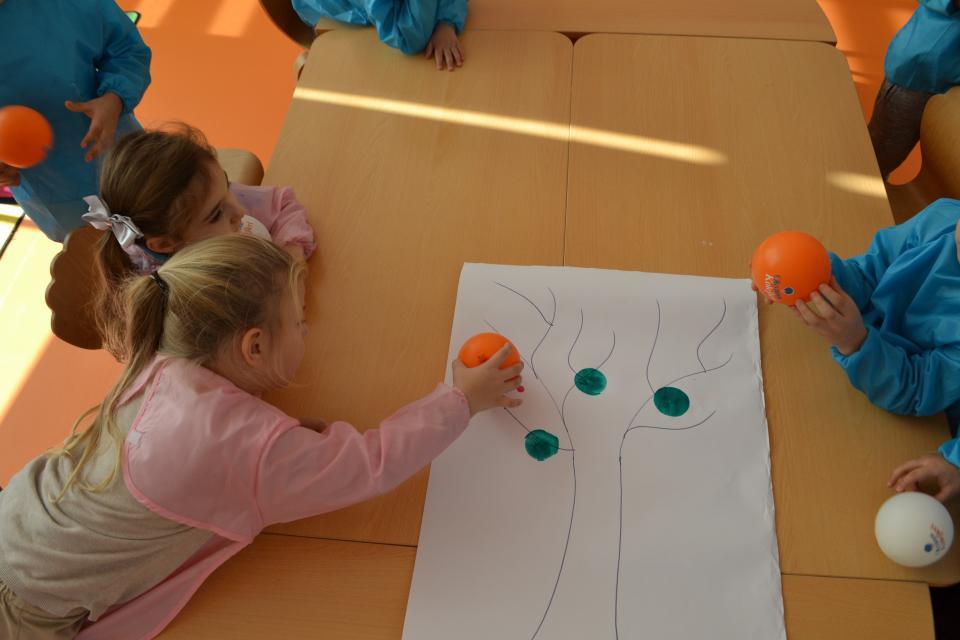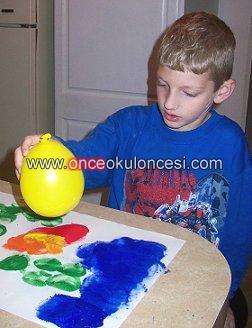The first image is the image on the left, the second image is the image on the right. For the images displayed, is the sentence "There are multiple children's heads visible." factually correct? Answer yes or no. Yes. The first image is the image on the left, the second image is the image on the right. Analyze the images presented: Is the assertion "The left image contains at least two children." valid? Answer yes or no. Yes. 